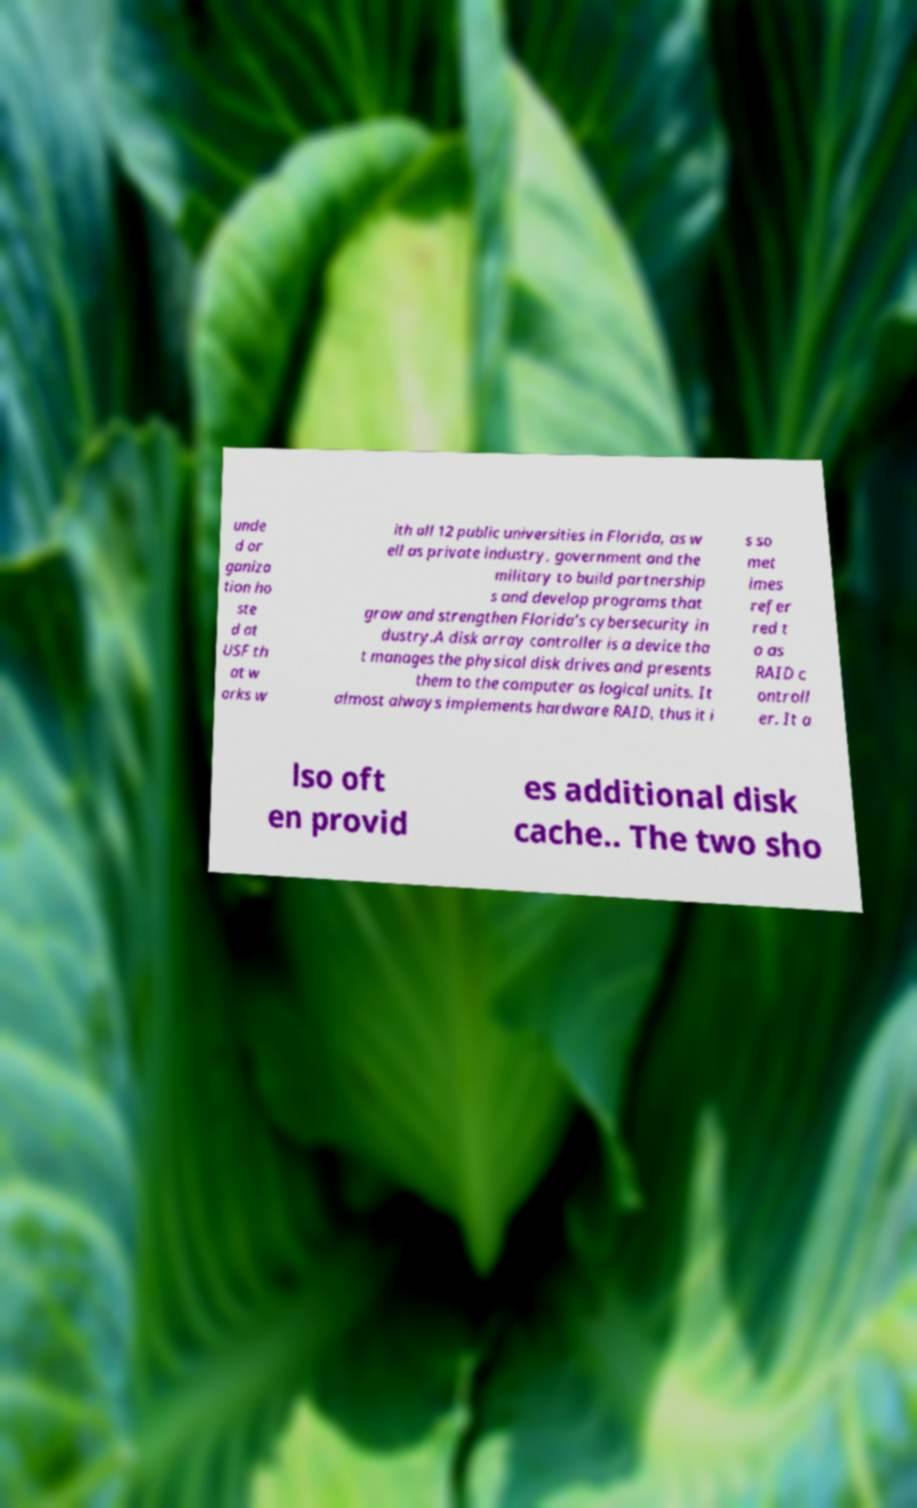Could you extract and type out the text from this image? unde d or ganiza tion ho ste d at USF th at w orks w ith all 12 public universities in Florida, as w ell as private industry, government and the military to build partnership s and develop programs that grow and strengthen Florida’s cybersecurity in dustry.A disk array controller is a device tha t manages the physical disk drives and presents them to the computer as logical units. It almost always implements hardware RAID, thus it i s so met imes refer red t o as RAID c ontroll er. It a lso oft en provid es additional disk cache.. The two sho 